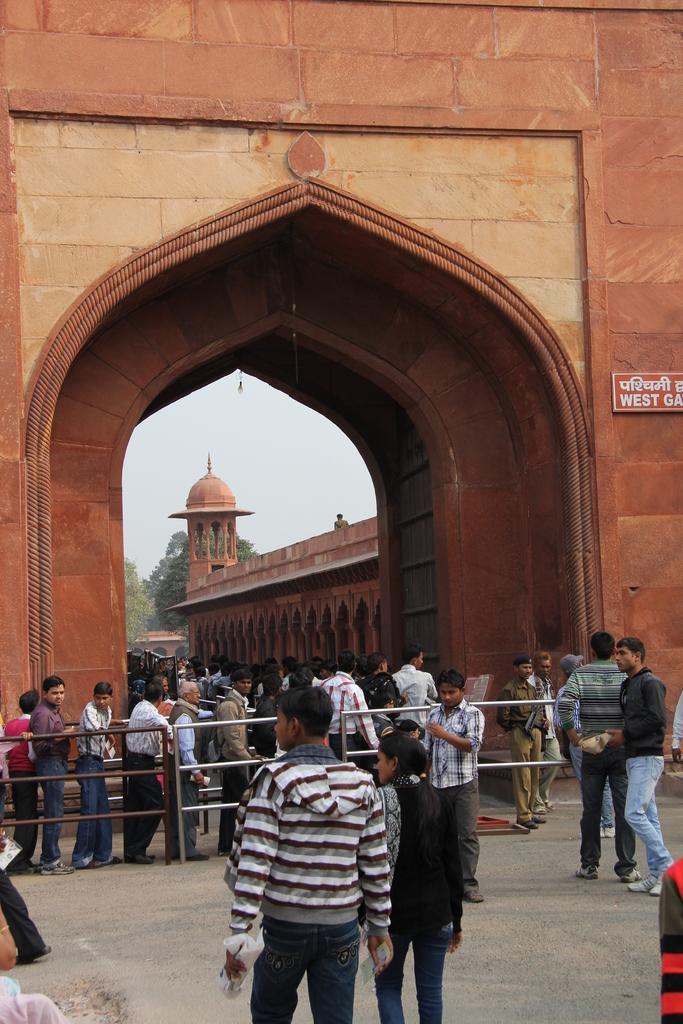How would you summarize this image in a sentence or two? In this picture I can see a arch under which there are some people standing beside the fencing and to the side there are some other people and a building to the other side of the arch. 